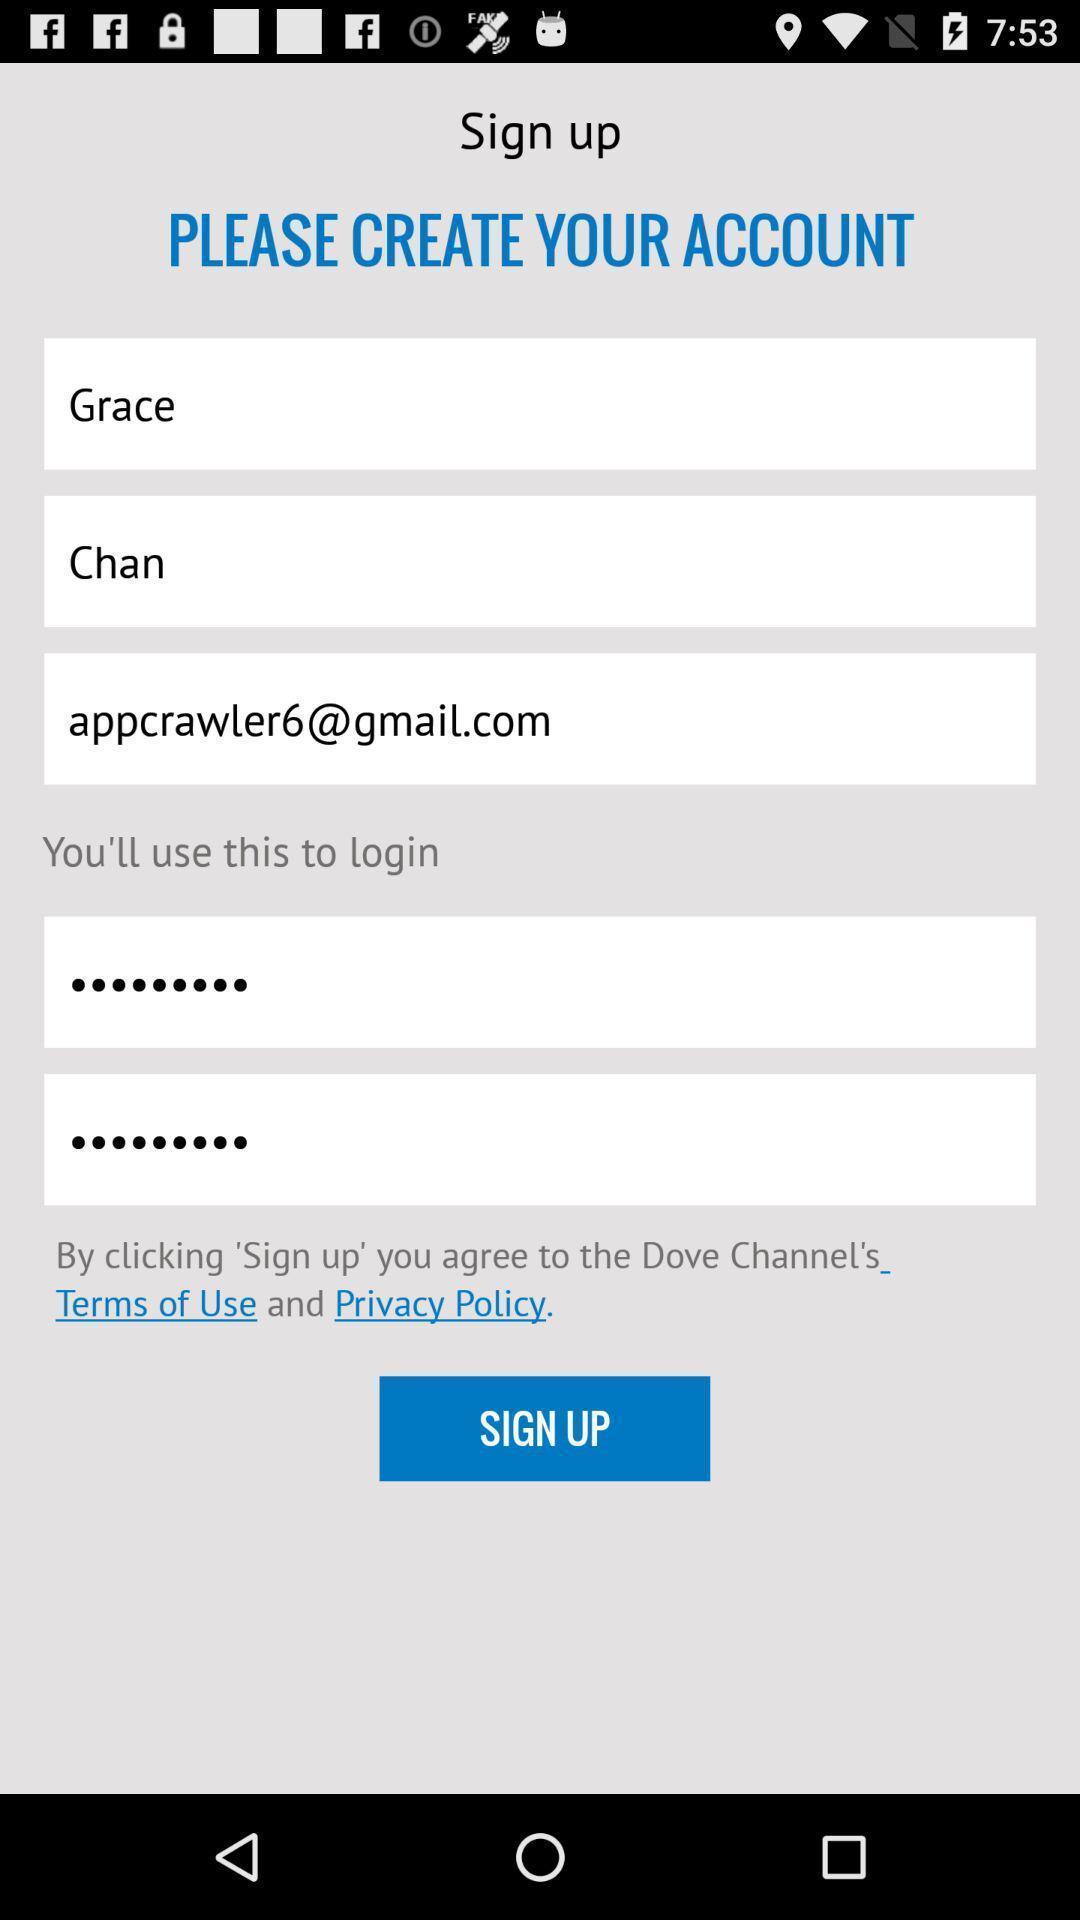Summarize the main components in this picture. Welcome page displaying to enter details. 